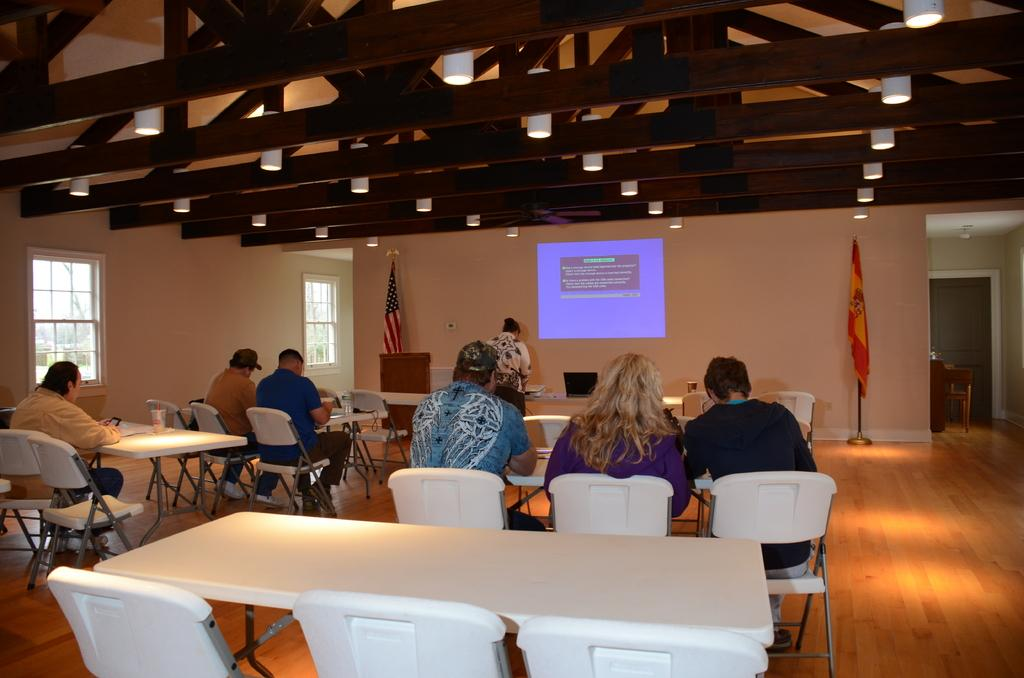What is located on top in the image? There are lights on top in the top in the image. What is on the wall in the image? There is a screen on the wall in the image. How many flags are visible in the image? There are two flags visible in the image. What type of furniture is present in the image? Chairs and tables are present in the image. What are the persons in the image doing? Persons are sitting on the chairs in the image. Is there any source of natural light in the image? Yes, there is a window in the image. How many dust particles can be seen floating near the lights in the image? There is no mention of dust particles in the image, so it is not possible to determine their number. What type of appliance is present on the table in the image? There is no appliance mentioned or visible in the image. 